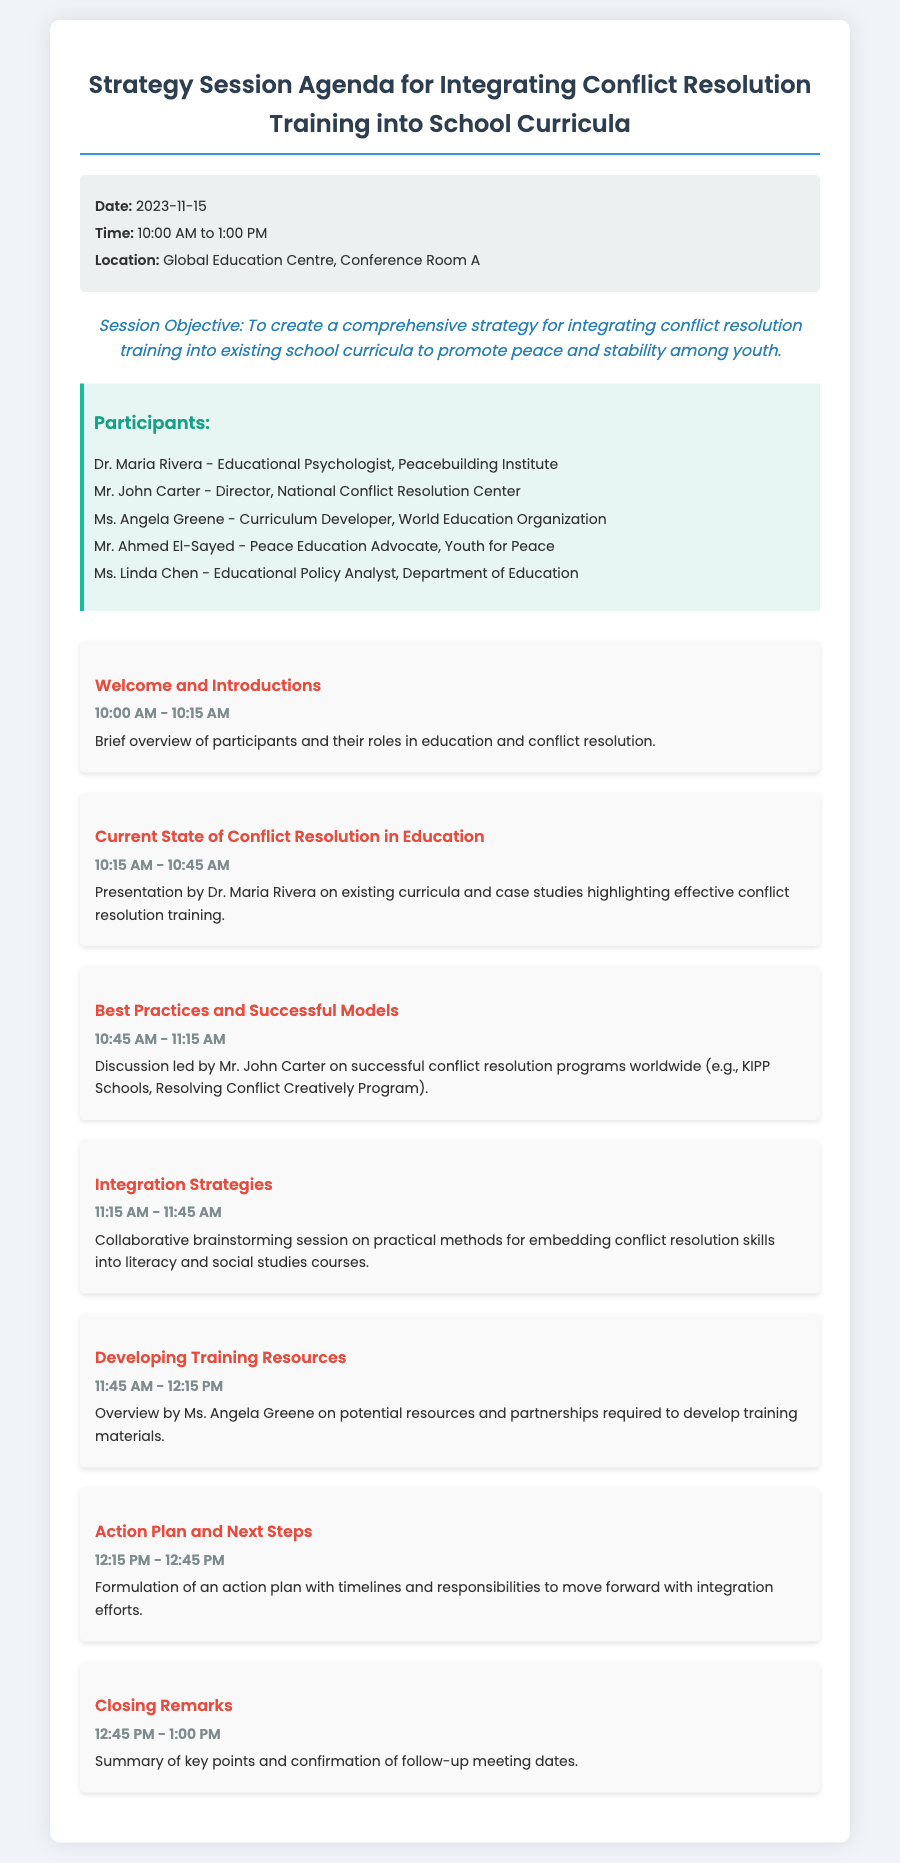What is the date of the session? The date of the session is specified in the document under the meta-info section.
Answer: 2023-11-15 Who is the Educational Psychologist? The document lists participants and their roles, identifying Dr. Maria Rivera as the Educational Psychologist.
Answer: Dr. Maria Rivera What time does the session start? The start time is mentioned in the meta-info section of the document.
Answer: 10:00 AM What topic is discussed at 10:45 AM? The agenda item timings and topics are detailed, showing that the topic for this time is led by Mr. John Carter.
Answer: Best Practices and Successful Models What is the objective of the session? The session objective is clearly stated at the beginning of the document, outlining the main goal of the meeting.
Answer: To create a comprehensive strategy for integrating conflict resolution training into existing school curricula to promote peace and stability What is the closing time of the session? The closing time is indicated in the agenda under the last item.
Answer: 1:00 PM What is the location of the strategy session? The document provides the location in the meta-info section.
Answer: Global Education Centre, Conference Room A How long is the presentation on current state of conflict resolution? The document specifies the duration for each agenda item, indicating the time allotted for this presentation.
Answer: 30 minutes Who provides an overview of potential resources for training materials? The document identifies that Ms. Angela Greene gives this overview during the session.
Answer: Ms. Angela Greene 